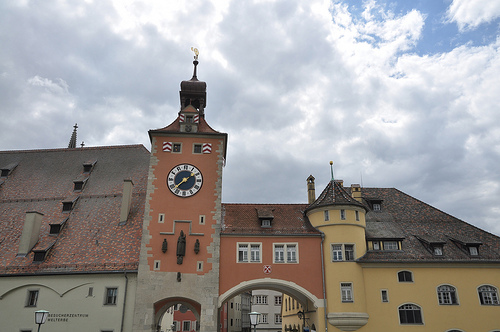Please provide a short description for this region: [0.51, 0.28, 0.65, 0.42]. This is a cloud in the sky. 